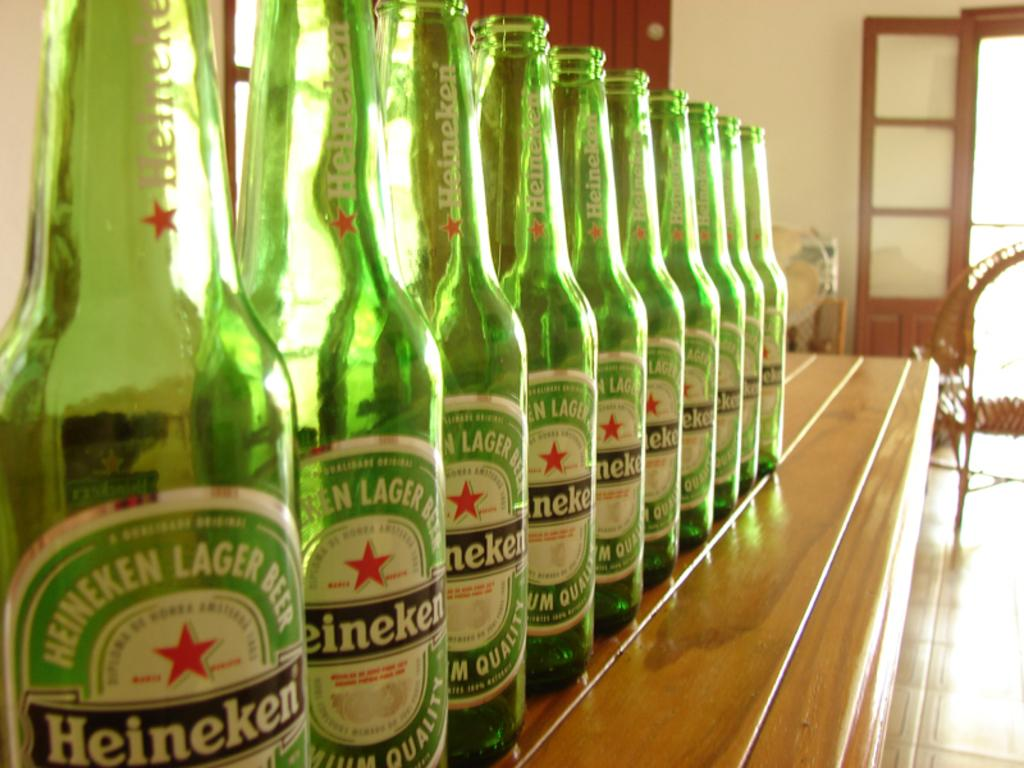<image>
Relay a brief, clear account of the picture shown. a row of green heineken lager beer bottles on a counter 